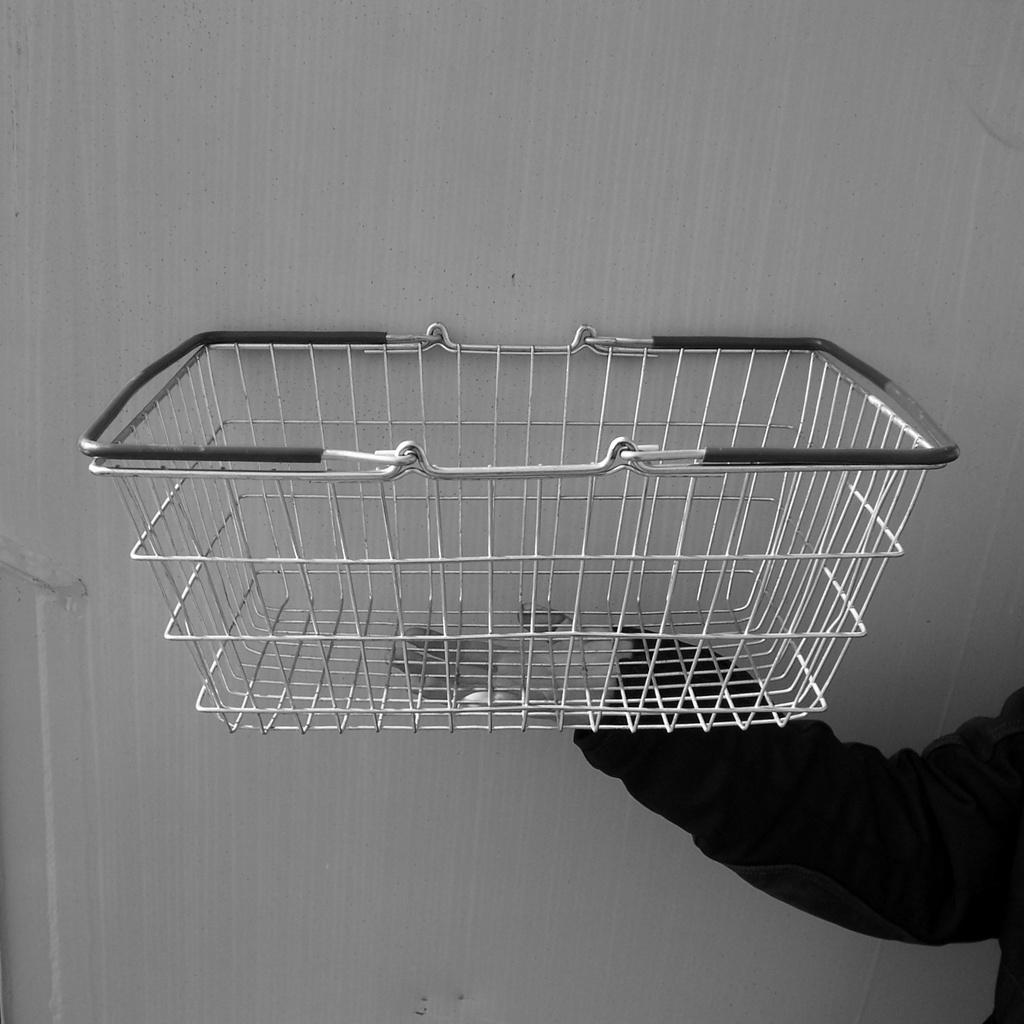What is the main object in the center of the image? There is a cage in the center of the image. Who or what is holding the cage? The cage is being held in a hand. What type of curve can be seen in the image? There is no curve present in the image; it features a cage being held in a hand. How many frogs are visible in the image? There are no frogs present in the image. 